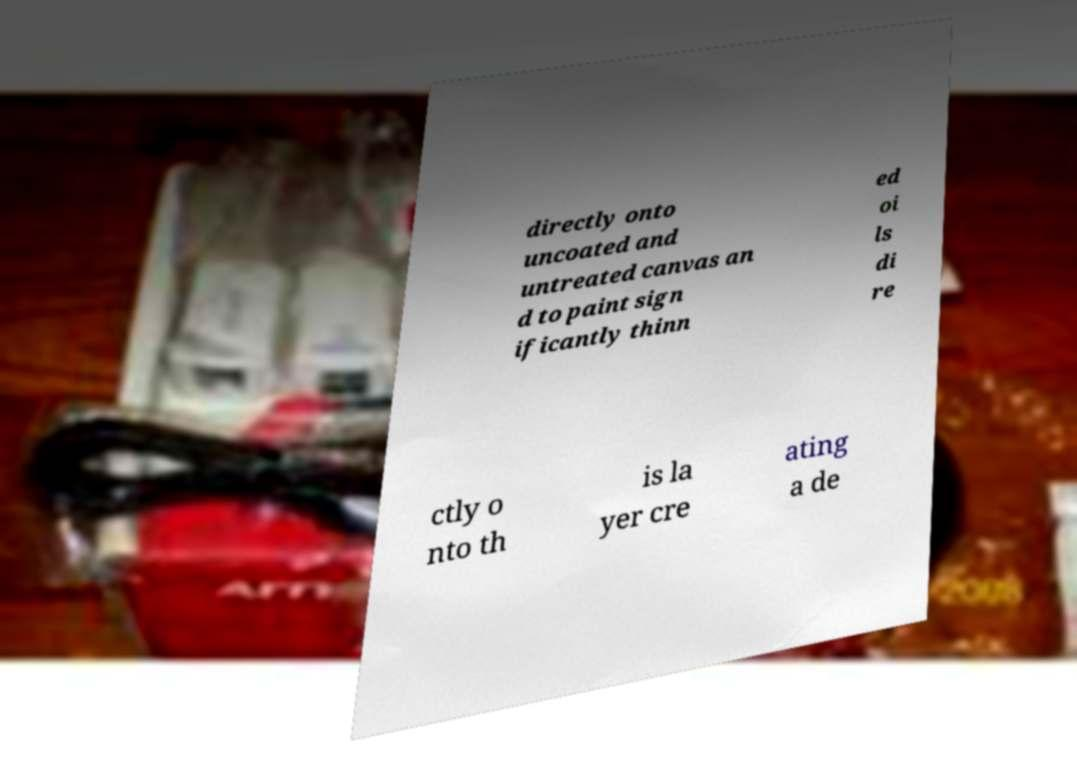What messages or text are displayed in this image? I need them in a readable, typed format. directly onto uncoated and untreated canvas an d to paint sign ificantly thinn ed oi ls di re ctly o nto th is la yer cre ating a de 